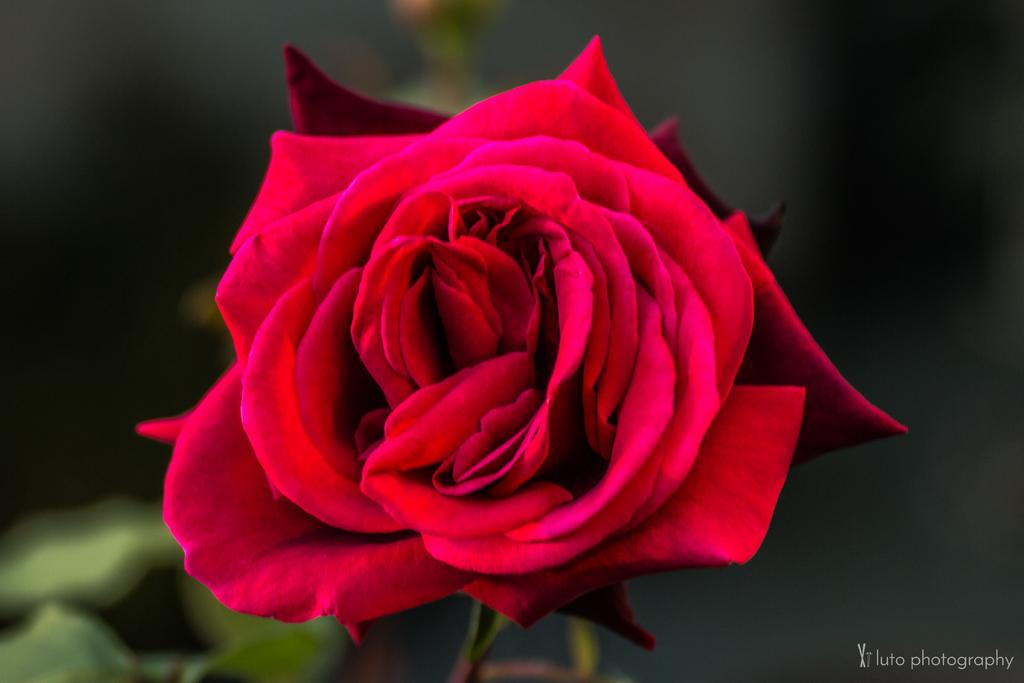What type of flower can be seen in the image? There is a red color flower present in the image. Can you describe the background of the image? The background of the image is blurred. Is there any additional information or marking in the image? Yes, there is a watermark in the bottom right corner of the image. How many fangs can be seen on the flower in the image? There are no fangs present on the flower in the image, as flowers do not have fangs. 